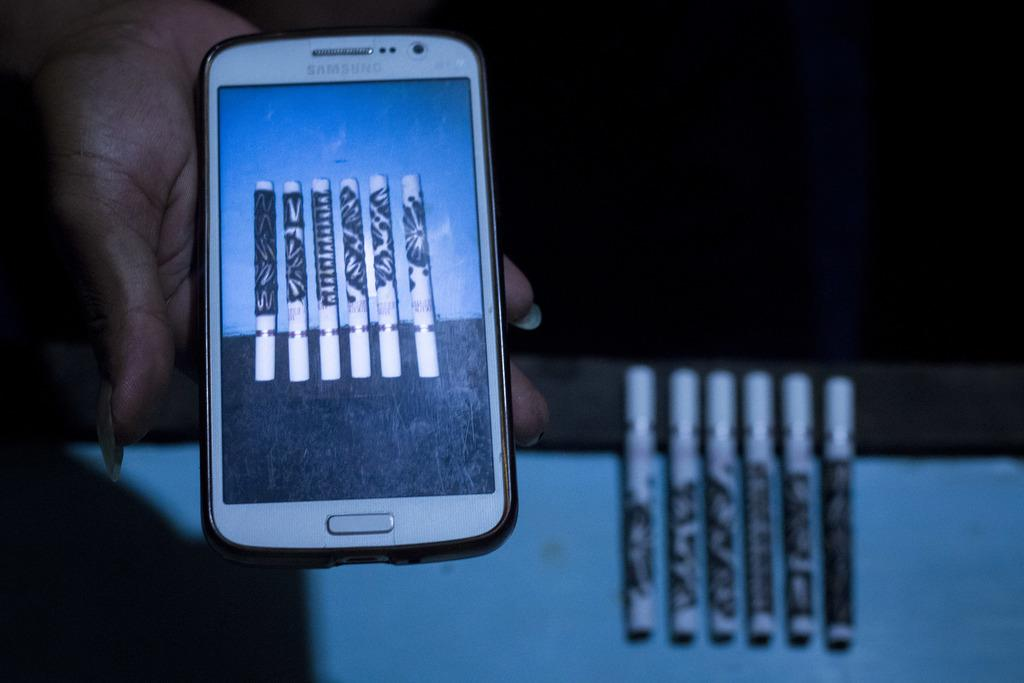<image>
Write a terse but informative summary of the picture. A Samsung device in a hand with a picture of markers or vape pens on it. 